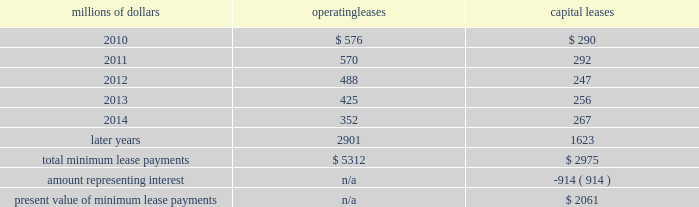14 .
Leases we lease certain locomotives , freight cars , and other property .
The consolidated statement of financial position as of december 31 , 2009 and 2008 included $ 2754 million , net of $ 927 million of accumulated depreciation , and $ 2024 million , net of $ 869 million of accumulated depreciation , respectively , for properties held under capital leases .
A charge to income resulting from the depreciation for assets held under capital leases is included within depreciation expense in our consolidated statements of income .
Future minimum lease payments for operating and capital leases with initial or remaining non-cancelable lease terms in excess of one year as of december 31 , 2009 were as follows : millions of dollars operating leases capital leases .
The majority of capital lease payments relate to locomotives .
Rent expense for operating leases with terms exceeding one month was $ 686 million in 2009 , $ 747 million in 2008 , and $ 810 million in 2007 .
When cash rental payments are not made on a straight-line basis , we recognize variable rental expense on a straight-line basis over the lease term .
Contingent rentals and sub-rentals are not significant .
15 .
Commitments and contingencies asserted and unasserted claims 2013 various claims and lawsuits are pending against us and certain of our subsidiaries .
We cannot fully determine the effect of all asserted and unasserted claims on our consolidated results of operations , financial condition , or liquidity ; however , to the extent possible , where asserted and unasserted claims are considered probable and where such claims can be reasonably estimated , we have recorded a liability .
We do not expect that any known lawsuits , claims , environmental costs , commitments , contingent liabilities , or guarantees will have a material adverse effect on our consolidated results of operations , financial condition , or liquidity after taking into account liabilities and insurance recoveries previously recorded for these matters .
Personal injury 2013 the cost of personal injuries to employees and others related to our activities is charged to expense based on estimates of the ultimate cost and number of incidents each year .
We use third-party actuaries to assist us in measuring the expense and liability , including unasserted claims .
The federal employers 2019 liability act ( fela ) governs compensation for work-related accidents .
Under fela , damages are assessed based on a finding of fault through litigation or out-of-court settlements .
We offer a comprehensive variety of services and rehabilitation programs for employees who are injured at .
What percent of total minimum operating lease payments are due in 2012? 
Computations: (488 / 5312)
Answer: 0.09187. 